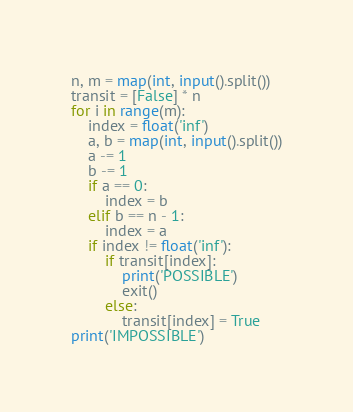<code> <loc_0><loc_0><loc_500><loc_500><_Python_>n, m = map(int, input().split())
transit = [False] * n
for i in range(m):
    index = float('inf')
    a, b = map(int, input().split())
    a -= 1
    b -= 1
    if a == 0:
        index = b
    elif b == n - 1:
        index = a
    if index != float('inf'):
        if transit[index]:
            print('POSSIBLE')
            exit()
        else:
            transit[index] = True
print('IMPOSSIBLE')</code> 